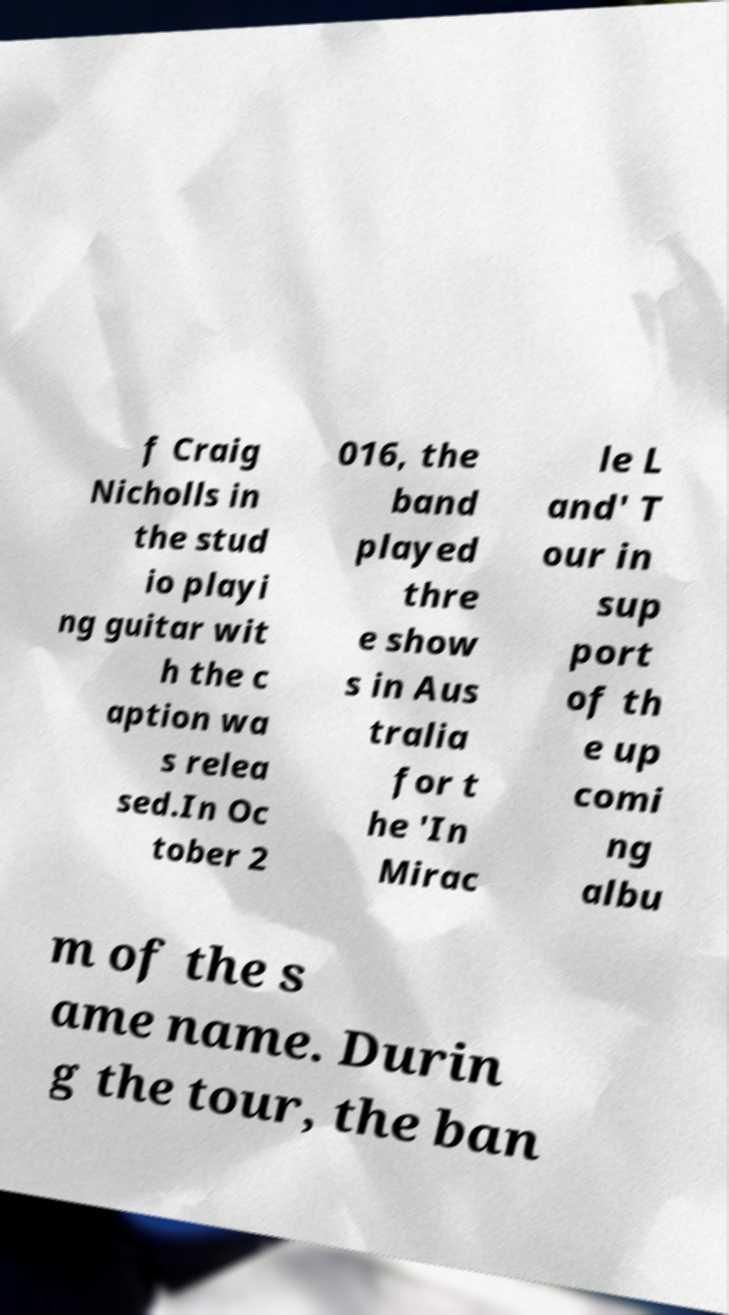Please read and relay the text visible in this image. What does it say? f Craig Nicholls in the stud io playi ng guitar wit h the c aption wa s relea sed.In Oc tober 2 016, the band played thre e show s in Aus tralia for t he 'In Mirac le L and' T our in sup port of th e up comi ng albu m of the s ame name. Durin g the tour, the ban 